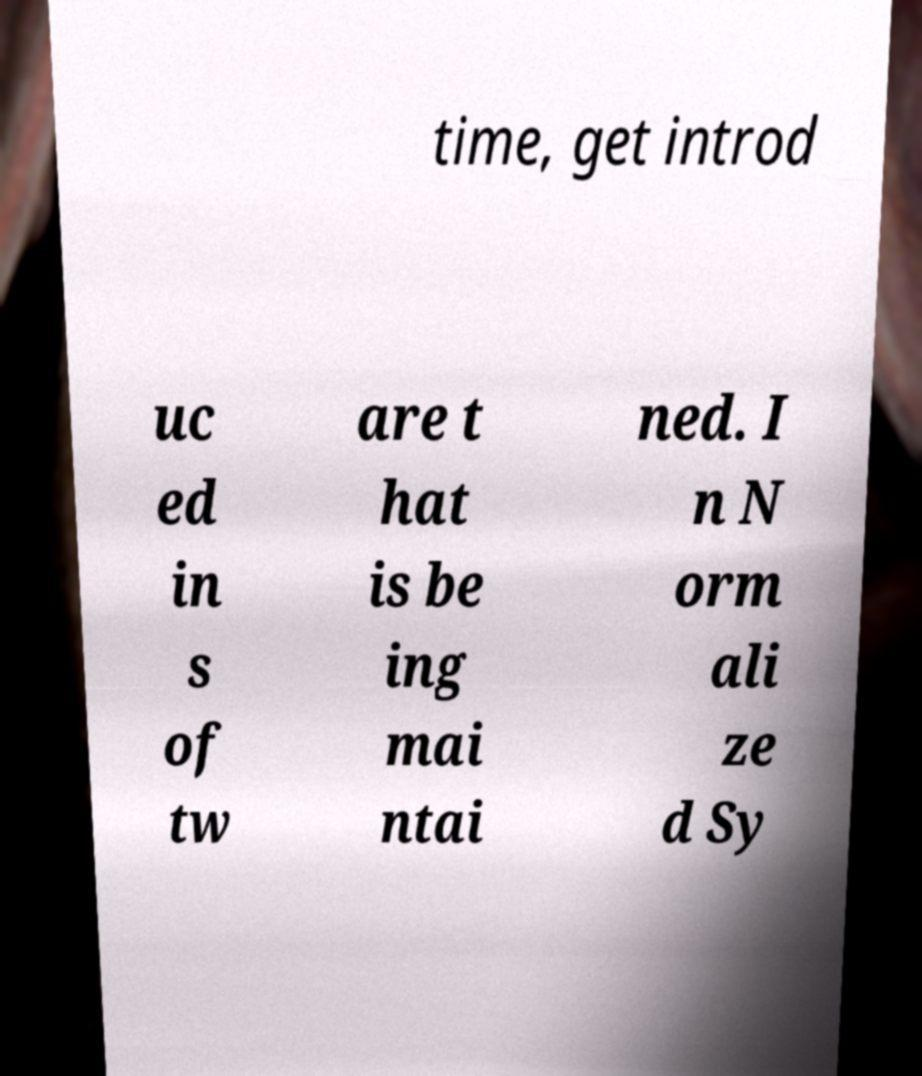Could you assist in decoding the text presented in this image and type it out clearly? time, get introd uc ed in s of tw are t hat is be ing mai ntai ned. I n N orm ali ze d Sy 